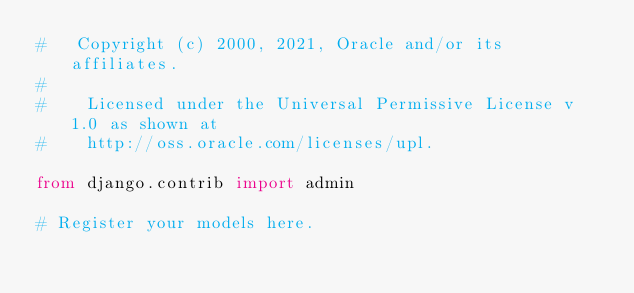<code> <loc_0><loc_0><loc_500><loc_500><_Python_>#   Copyright (c) 2000, 2021, Oracle and/or its affiliates.
#
#    Licensed under the Universal Permissive License v 1.0 as shown at
#    http://oss.oracle.com/licenses/upl.

from django.contrib import admin

# Register your models here.
</code> 